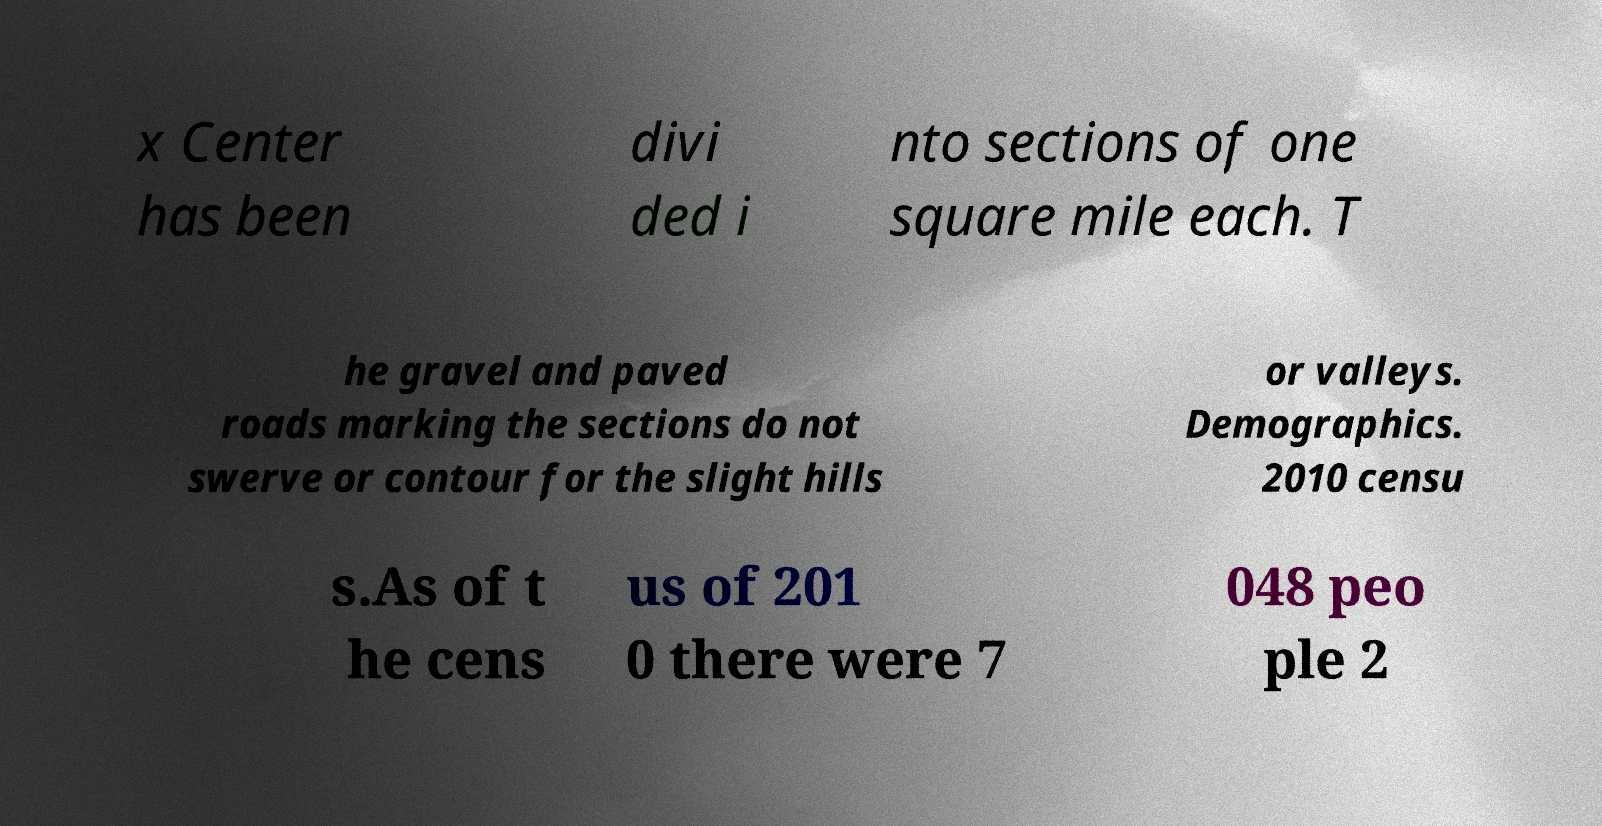Can you accurately transcribe the text from the provided image for me? x Center has been divi ded i nto sections of one square mile each. T he gravel and paved roads marking the sections do not swerve or contour for the slight hills or valleys. Demographics. 2010 censu s.As of t he cens us of 201 0 there were 7 048 peo ple 2 